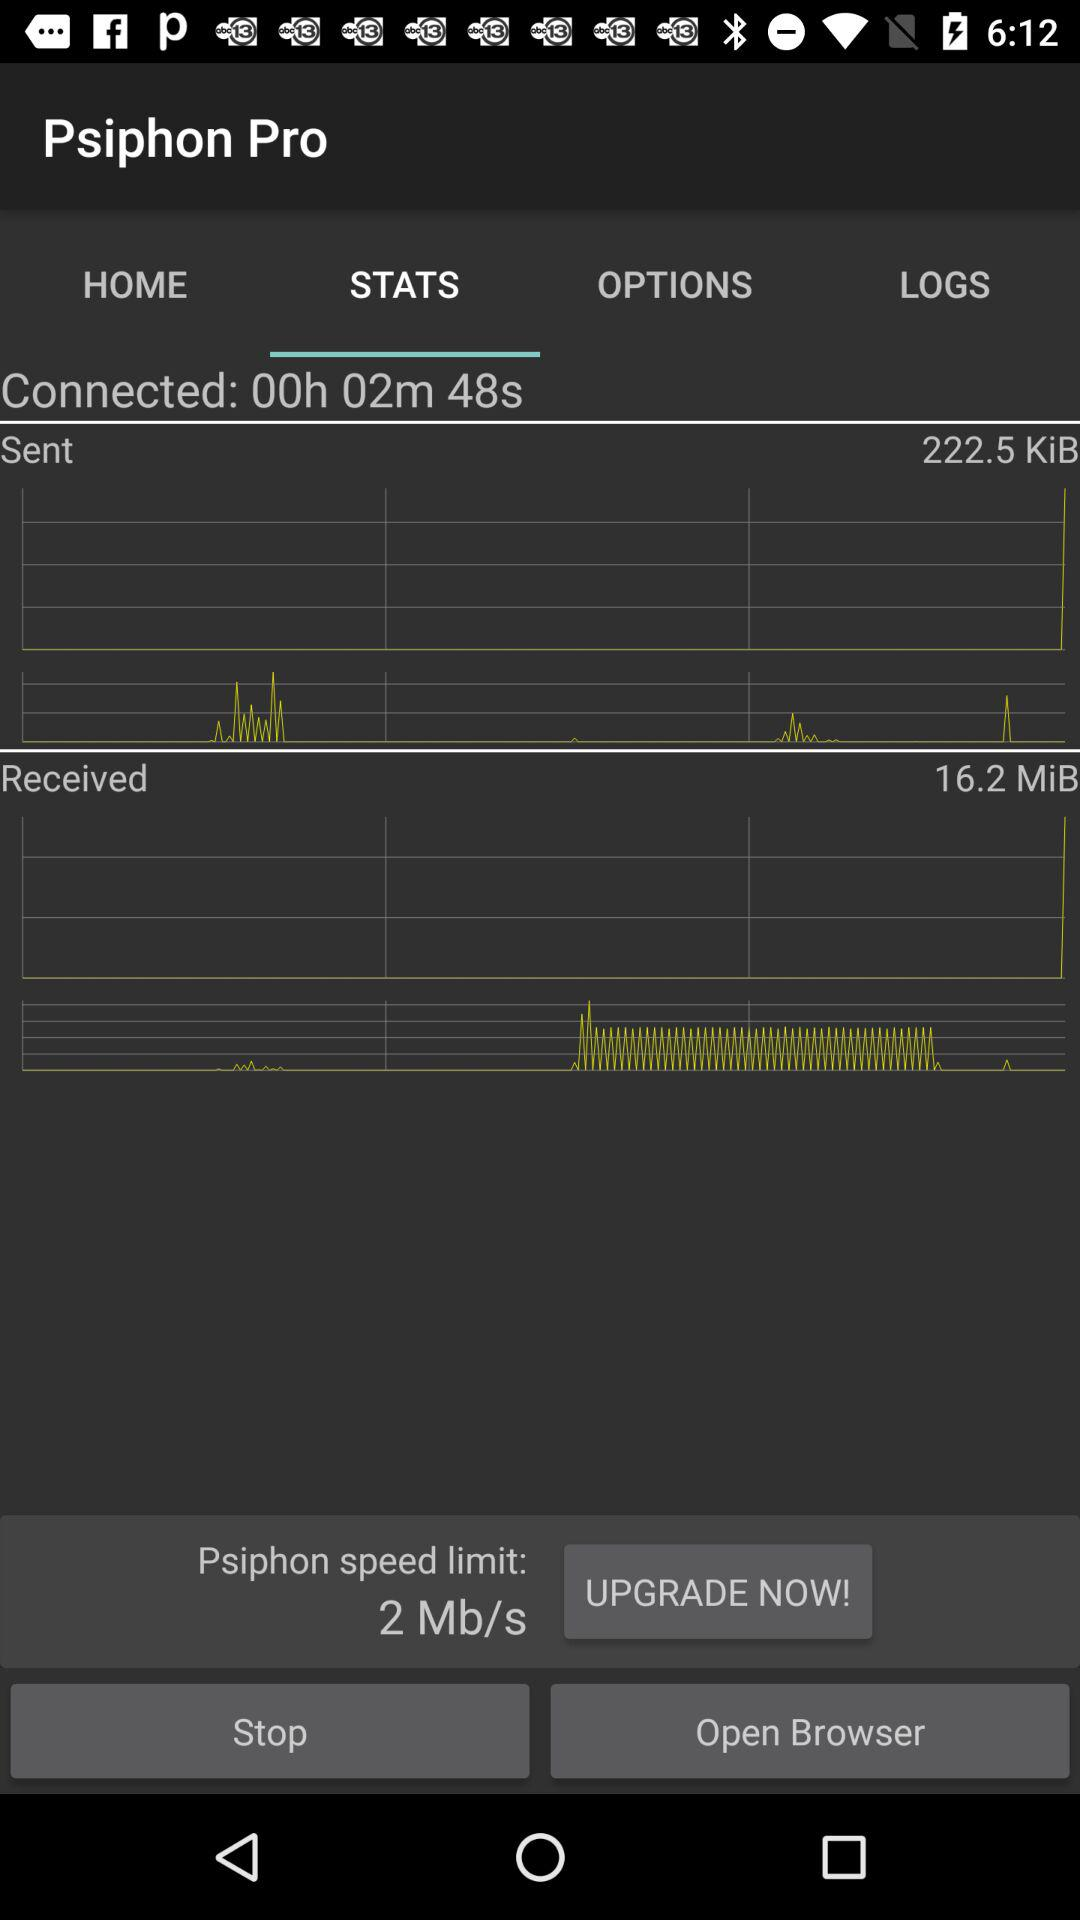What is the Psiphon speed limit? The Psiphon speed limit is 2 Mb/s. 